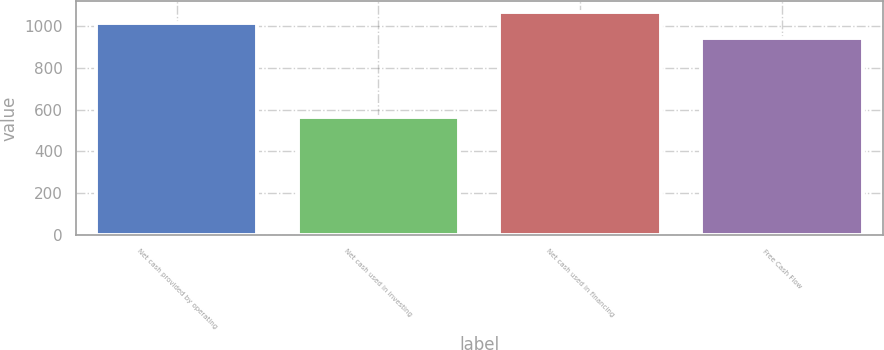<chart> <loc_0><loc_0><loc_500><loc_500><bar_chart><fcel>Net cash provided by operating<fcel>Net cash used in investing<fcel>Net cash used in financing<fcel>Free Cash Flow<nl><fcel>1018.6<fcel>564.9<fcel>1068.56<fcel>944<nl></chart> 